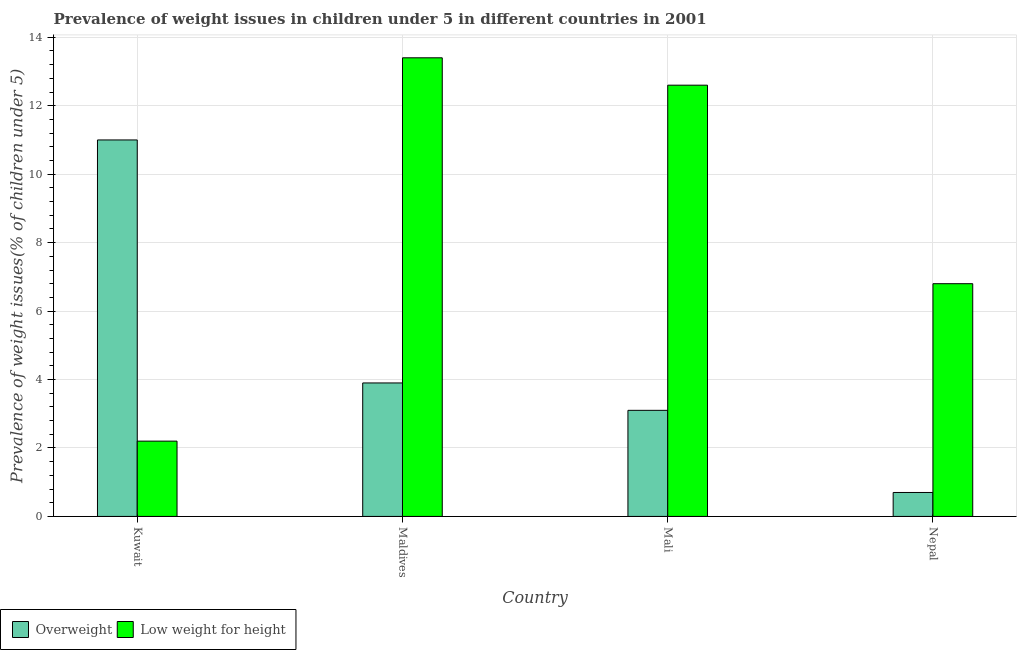How many groups of bars are there?
Ensure brevity in your answer.  4. Are the number of bars per tick equal to the number of legend labels?
Your answer should be very brief. Yes. Are the number of bars on each tick of the X-axis equal?
Offer a terse response. Yes. How many bars are there on the 3rd tick from the left?
Your answer should be compact. 2. How many bars are there on the 1st tick from the right?
Provide a short and direct response. 2. What is the label of the 2nd group of bars from the left?
Provide a short and direct response. Maldives. In how many cases, is the number of bars for a given country not equal to the number of legend labels?
Offer a terse response. 0. What is the percentage of overweight children in Mali?
Ensure brevity in your answer.  3.1. Across all countries, what is the maximum percentage of underweight children?
Keep it short and to the point. 13.4. Across all countries, what is the minimum percentage of underweight children?
Ensure brevity in your answer.  2.2. In which country was the percentage of overweight children maximum?
Offer a very short reply. Kuwait. In which country was the percentage of overweight children minimum?
Ensure brevity in your answer.  Nepal. What is the total percentage of overweight children in the graph?
Provide a succinct answer. 18.7. What is the difference between the percentage of underweight children in Mali and that in Nepal?
Keep it short and to the point. 5.8. What is the difference between the percentage of underweight children in Maldives and the percentage of overweight children in Nepal?
Offer a very short reply. 12.7. What is the average percentage of underweight children per country?
Offer a terse response. 8.75. What is the difference between the percentage of overweight children and percentage of underweight children in Maldives?
Provide a short and direct response. -9.5. In how many countries, is the percentage of overweight children greater than 12.8 %?
Ensure brevity in your answer.  0. What is the ratio of the percentage of overweight children in Kuwait to that in Mali?
Offer a terse response. 3.55. Is the percentage of underweight children in Kuwait less than that in Mali?
Your answer should be very brief. Yes. Is the difference between the percentage of underweight children in Kuwait and Maldives greater than the difference between the percentage of overweight children in Kuwait and Maldives?
Your answer should be very brief. No. What is the difference between the highest and the second highest percentage of overweight children?
Ensure brevity in your answer.  7.1. What is the difference between the highest and the lowest percentage of underweight children?
Your answer should be compact. 11.2. In how many countries, is the percentage of underweight children greater than the average percentage of underweight children taken over all countries?
Offer a very short reply. 2. Is the sum of the percentage of overweight children in Maldives and Nepal greater than the maximum percentage of underweight children across all countries?
Give a very brief answer. No. What does the 1st bar from the left in Mali represents?
Offer a terse response. Overweight. What does the 1st bar from the right in Mali represents?
Offer a very short reply. Low weight for height. How many bars are there?
Make the answer very short. 8. How many countries are there in the graph?
Your response must be concise. 4. What is the difference between two consecutive major ticks on the Y-axis?
Offer a terse response. 2. Does the graph contain any zero values?
Make the answer very short. No. Does the graph contain grids?
Offer a terse response. Yes. Where does the legend appear in the graph?
Make the answer very short. Bottom left. How many legend labels are there?
Make the answer very short. 2. What is the title of the graph?
Your answer should be very brief. Prevalence of weight issues in children under 5 in different countries in 2001. Does "Under-5(female)" appear as one of the legend labels in the graph?
Offer a very short reply. No. What is the label or title of the X-axis?
Provide a succinct answer. Country. What is the label or title of the Y-axis?
Offer a very short reply. Prevalence of weight issues(% of children under 5). What is the Prevalence of weight issues(% of children under 5) of Overweight in Kuwait?
Ensure brevity in your answer.  11. What is the Prevalence of weight issues(% of children under 5) in Low weight for height in Kuwait?
Keep it short and to the point. 2.2. What is the Prevalence of weight issues(% of children under 5) of Overweight in Maldives?
Provide a succinct answer. 3.9. What is the Prevalence of weight issues(% of children under 5) in Low weight for height in Maldives?
Offer a terse response. 13.4. What is the Prevalence of weight issues(% of children under 5) of Overweight in Mali?
Provide a short and direct response. 3.1. What is the Prevalence of weight issues(% of children under 5) in Low weight for height in Mali?
Your answer should be compact. 12.6. What is the Prevalence of weight issues(% of children under 5) of Overweight in Nepal?
Your answer should be very brief. 0.7. What is the Prevalence of weight issues(% of children under 5) in Low weight for height in Nepal?
Offer a very short reply. 6.8. Across all countries, what is the maximum Prevalence of weight issues(% of children under 5) in Low weight for height?
Make the answer very short. 13.4. Across all countries, what is the minimum Prevalence of weight issues(% of children under 5) in Overweight?
Ensure brevity in your answer.  0.7. Across all countries, what is the minimum Prevalence of weight issues(% of children under 5) of Low weight for height?
Offer a very short reply. 2.2. What is the total Prevalence of weight issues(% of children under 5) of Overweight in the graph?
Make the answer very short. 18.7. What is the total Prevalence of weight issues(% of children under 5) in Low weight for height in the graph?
Your answer should be compact. 35. What is the difference between the Prevalence of weight issues(% of children under 5) in Low weight for height in Kuwait and that in Maldives?
Offer a terse response. -11.2. What is the difference between the Prevalence of weight issues(% of children under 5) of Overweight in Maldives and that in Mali?
Ensure brevity in your answer.  0.8. What is the difference between the Prevalence of weight issues(% of children under 5) of Overweight in Maldives and that in Nepal?
Provide a short and direct response. 3.2. What is the difference between the Prevalence of weight issues(% of children under 5) of Overweight in Mali and that in Nepal?
Your answer should be very brief. 2.4. What is the difference between the Prevalence of weight issues(% of children under 5) of Low weight for height in Mali and that in Nepal?
Keep it short and to the point. 5.8. What is the difference between the Prevalence of weight issues(% of children under 5) of Overweight in Kuwait and the Prevalence of weight issues(% of children under 5) of Low weight for height in Maldives?
Make the answer very short. -2.4. What is the difference between the Prevalence of weight issues(% of children under 5) in Overweight in Kuwait and the Prevalence of weight issues(% of children under 5) in Low weight for height in Nepal?
Ensure brevity in your answer.  4.2. What is the difference between the Prevalence of weight issues(% of children under 5) of Overweight in Maldives and the Prevalence of weight issues(% of children under 5) of Low weight for height in Mali?
Give a very brief answer. -8.7. What is the difference between the Prevalence of weight issues(% of children under 5) in Overweight in Maldives and the Prevalence of weight issues(% of children under 5) in Low weight for height in Nepal?
Keep it short and to the point. -2.9. What is the difference between the Prevalence of weight issues(% of children under 5) in Overweight in Mali and the Prevalence of weight issues(% of children under 5) in Low weight for height in Nepal?
Keep it short and to the point. -3.7. What is the average Prevalence of weight issues(% of children under 5) of Overweight per country?
Give a very brief answer. 4.67. What is the average Prevalence of weight issues(% of children under 5) of Low weight for height per country?
Make the answer very short. 8.75. What is the difference between the Prevalence of weight issues(% of children under 5) of Overweight and Prevalence of weight issues(% of children under 5) of Low weight for height in Nepal?
Make the answer very short. -6.1. What is the ratio of the Prevalence of weight issues(% of children under 5) in Overweight in Kuwait to that in Maldives?
Provide a succinct answer. 2.82. What is the ratio of the Prevalence of weight issues(% of children under 5) of Low weight for height in Kuwait to that in Maldives?
Keep it short and to the point. 0.16. What is the ratio of the Prevalence of weight issues(% of children under 5) of Overweight in Kuwait to that in Mali?
Your answer should be very brief. 3.55. What is the ratio of the Prevalence of weight issues(% of children under 5) in Low weight for height in Kuwait to that in Mali?
Give a very brief answer. 0.17. What is the ratio of the Prevalence of weight issues(% of children under 5) in Overweight in Kuwait to that in Nepal?
Your answer should be compact. 15.71. What is the ratio of the Prevalence of weight issues(% of children under 5) of Low weight for height in Kuwait to that in Nepal?
Give a very brief answer. 0.32. What is the ratio of the Prevalence of weight issues(% of children under 5) of Overweight in Maldives to that in Mali?
Provide a short and direct response. 1.26. What is the ratio of the Prevalence of weight issues(% of children under 5) in Low weight for height in Maldives to that in Mali?
Your response must be concise. 1.06. What is the ratio of the Prevalence of weight issues(% of children under 5) in Overweight in Maldives to that in Nepal?
Make the answer very short. 5.57. What is the ratio of the Prevalence of weight issues(% of children under 5) in Low weight for height in Maldives to that in Nepal?
Make the answer very short. 1.97. What is the ratio of the Prevalence of weight issues(% of children under 5) in Overweight in Mali to that in Nepal?
Keep it short and to the point. 4.43. What is the ratio of the Prevalence of weight issues(% of children under 5) of Low weight for height in Mali to that in Nepal?
Ensure brevity in your answer.  1.85. 